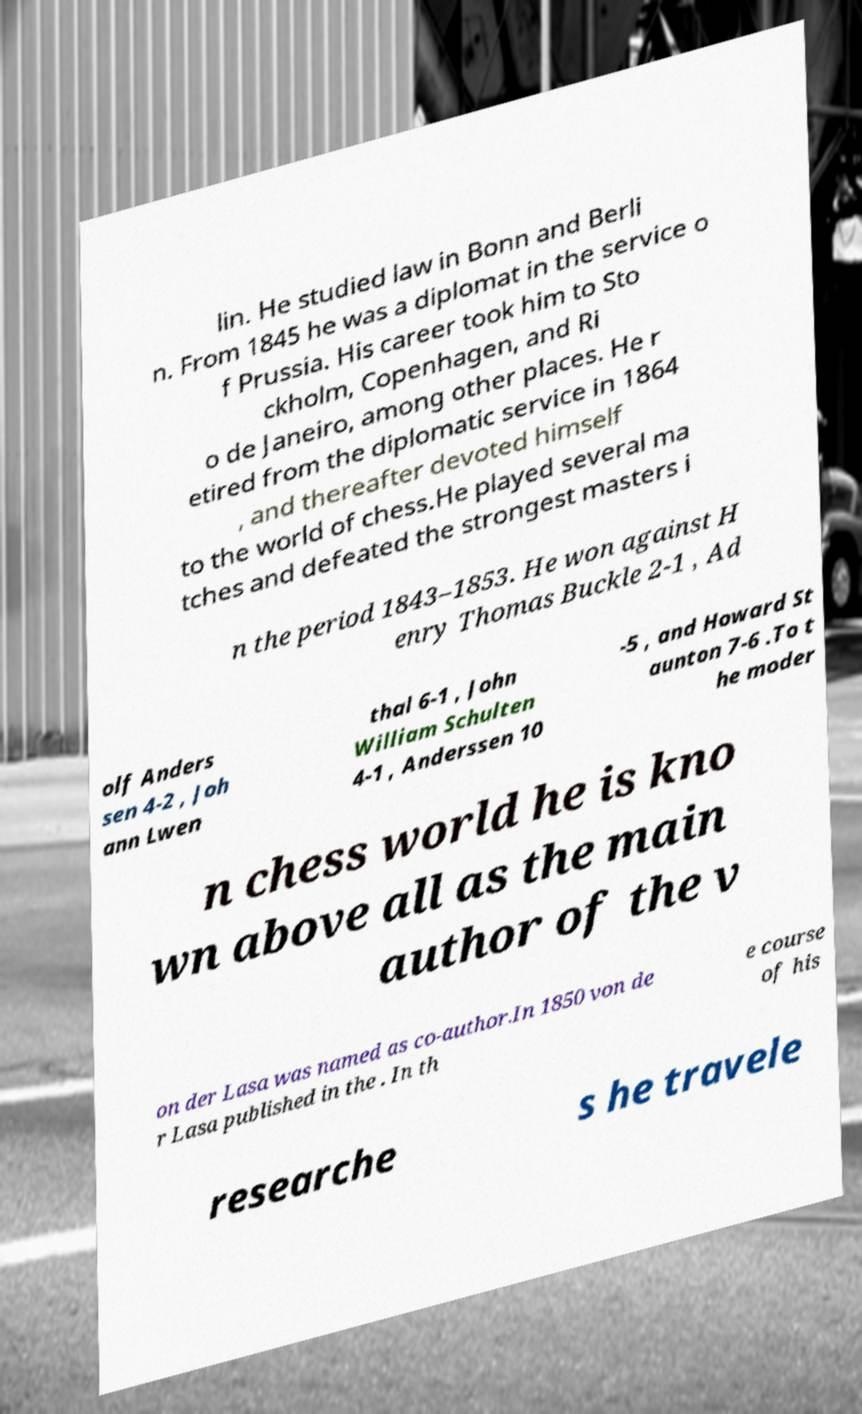Could you assist in decoding the text presented in this image and type it out clearly? lin. He studied law in Bonn and Berli n. From 1845 he was a diplomat in the service o f Prussia. His career took him to Sto ckholm, Copenhagen, and Ri o de Janeiro, among other places. He r etired from the diplomatic service in 1864 , and thereafter devoted himself to the world of chess.He played several ma tches and defeated the strongest masters i n the period 1843–1853. He won against H enry Thomas Buckle 2-1 , Ad olf Anders sen 4-2 , Joh ann Lwen thal 6-1 , John William Schulten 4-1 , Anderssen 10 -5 , and Howard St aunton 7-6 .To t he moder n chess world he is kno wn above all as the main author of the v on der Lasa was named as co-author.In 1850 von de r Lasa published in the . In th e course of his researche s he travele 